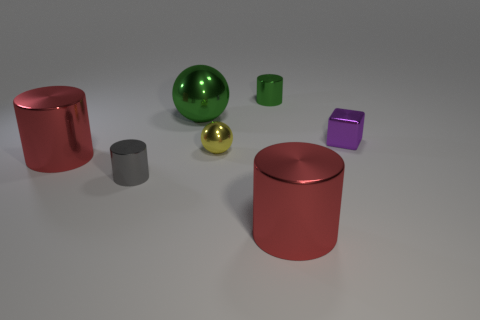Add 1 small cyan balls. How many objects exist? 8 Subtract all balls. How many objects are left? 5 Subtract 0 blue cubes. How many objects are left? 7 Subtract all purple objects. Subtract all small shiny cylinders. How many objects are left? 4 Add 6 tiny shiny cylinders. How many tiny shiny cylinders are left? 8 Add 3 tiny gray cylinders. How many tiny gray cylinders exist? 4 